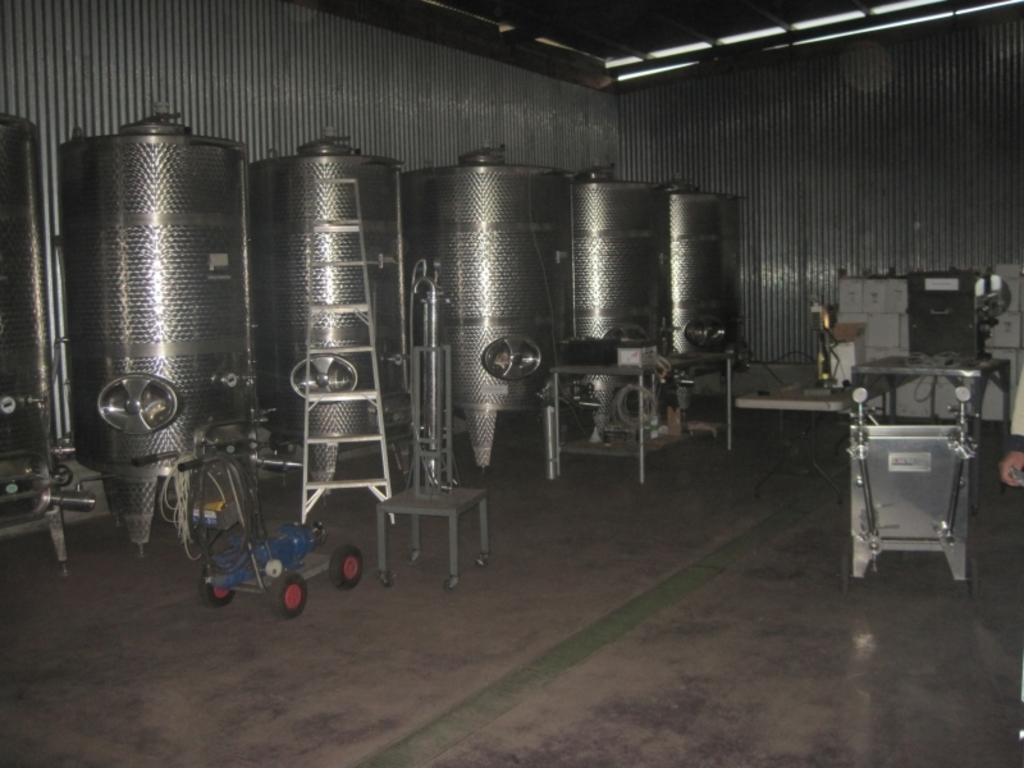What type of containers are present in the image? There are metal tanks in the image in the image. What is the color of the metal tanks? The metal tanks are silver in color. What other items can be seen in the image besides the metal tanks? There is other equipment visible in the image. What type of doors are present in the image? There are steel doors in the image. What part of the room is visible in the image? The ceiling is visible in the image. What type of whip is being used to prepare food in the image? There is no whip or food preparation visible in the image; it features include metal tanks, other equipment, steel doors, and a visible ceiling. 